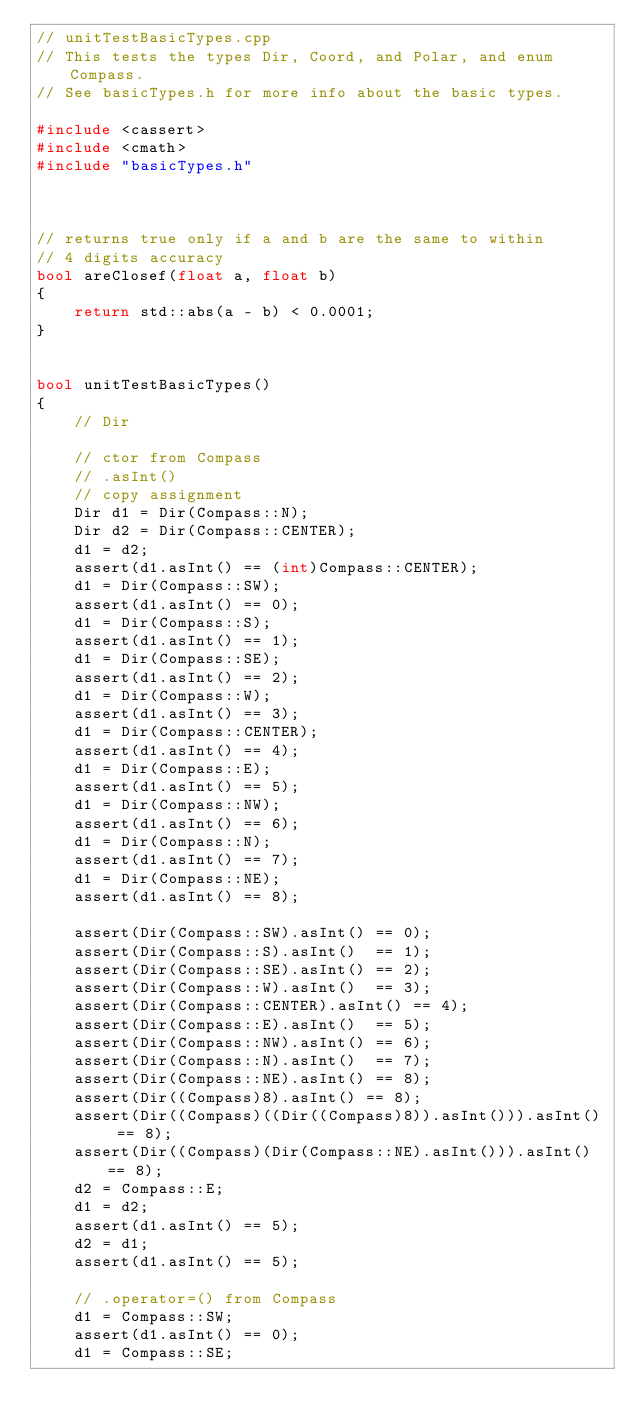<code> <loc_0><loc_0><loc_500><loc_500><_C++_>// unitTestBasicTypes.cpp
// This tests the types Dir, Coord, and Polar, and enum Compass.
// See basicTypes.h for more info about the basic types.

#include <cassert>
#include <cmath>
#include "basicTypes.h"



// returns true only if a and b are the same to within
// 4 digits accuracy
bool areClosef(float a, float b)
{
    return std::abs(a - b) < 0.0001;
}


bool unitTestBasicTypes()
{
    // Dir

    // ctor from Compass
    // .asInt()
    // copy assignment
    Dir d1 = Dir(Compass::N);
    Dir d2 = Dir(Compass::CENTER);
    d1 = d2;
    assert(d1.asInt() == (int)Compass::CENTER);
    d1 = Dir(Compass::SW);
    assert(d1.asInt() == 0);
    d1 = Dir(Compass::S);
    assert(d1.asInt() == 1);
    d1 = Dir(Compass::SE);
    assert(d1.asInt() == 2);
    d1 = Dir(Compass::W);
    assert(d1.asInt() == 3);
    d1 = Dir(Compass::CENTER);
    assert(d1.asInt() == 4);
    d1 = Dir(Compass::E);
    assert(d1.asInt() == 5);
    d1 = Dir(Compass::NW);
    assert(d1.asInt() == 6);
    d1 = Dir(Compass::N);
    assert(d1.asInt() == 7);
    d1 = Dir(Compass::NE);
    assert(d1.asInt() == 8);

    assert(Dir(Compass::SW).asInt() == 0);
    assert(Dir(Compass::S).asInt()  == 1);
    assert(Dir(Compass::SE).asInt() == 2);
    assert(Dir(Compass::W).asInt()  == 3);
    assert(Dir(Compass::CENTER).asInt() == 4);
    assert(Dir(Compass::E).asInt()  == 5);
    assert(Dir(Compass::NW).asInt() == 6);
    assert(Dir(Compass::N).asInt()  == 7);
    assert(Dir(Compass::NE).asInt() == 8);
    assert(Dir((Compass)8).asInt() == 8);
    assert(Dir((Compass)((Dir((Compass)8)).asInt())).asInt() == 8);
    assert(Dir((Compass)(Dir(Compass::NE).asInt())).asInt() == 8);
    d2 = Compass::E;
    d1 = d2;
    assert(d1.asInt() == 5);
    d2 = d1;
    assert(d1.asInt() == 5);

    // .operator=() from Compass
    d1 = Compass::SW;
    assert(d1.asInt() == 0);
    d1 = Compass::SE;</code> 